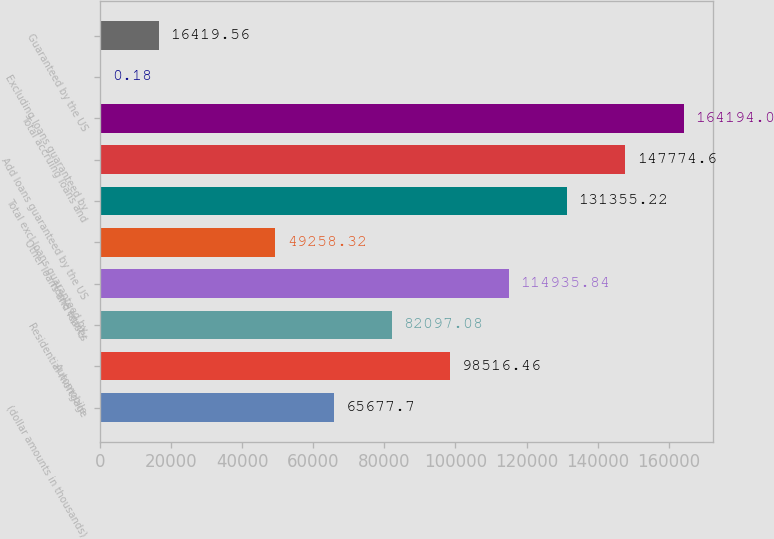<chart> <loc_0><loc_0><loc_500><loc_500><bar_chart><fcel>(dollar amounts in thousands)<fcel>Automobile<fcel>Residential mortgage<fcel>Home equity<fcel>Other loans and leases<fcel>Total excl loans guaranteed by<fcel>Add loans guaranteed by the US<fcel>Total accruing loans and<fcel>Excluding loans guaranteed by<fcel>Guaranteed by the US<nl><fcel>65677.7<fcel>98516.5<fcel>82097.1<fcel>114936<fcel>49258.3<fcel>131355<fcel>147775<fcel>164194<fcel>0.18<fcel>16419.6<nl></chart> 